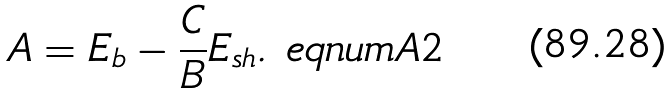Convert formula to latex. <formula><loc_0><loc_0><loc_500><loc_500>A = E _ { b } - \frac { C } { B } E _ { s h } . \ e q n u m { A 2 }</formula> 